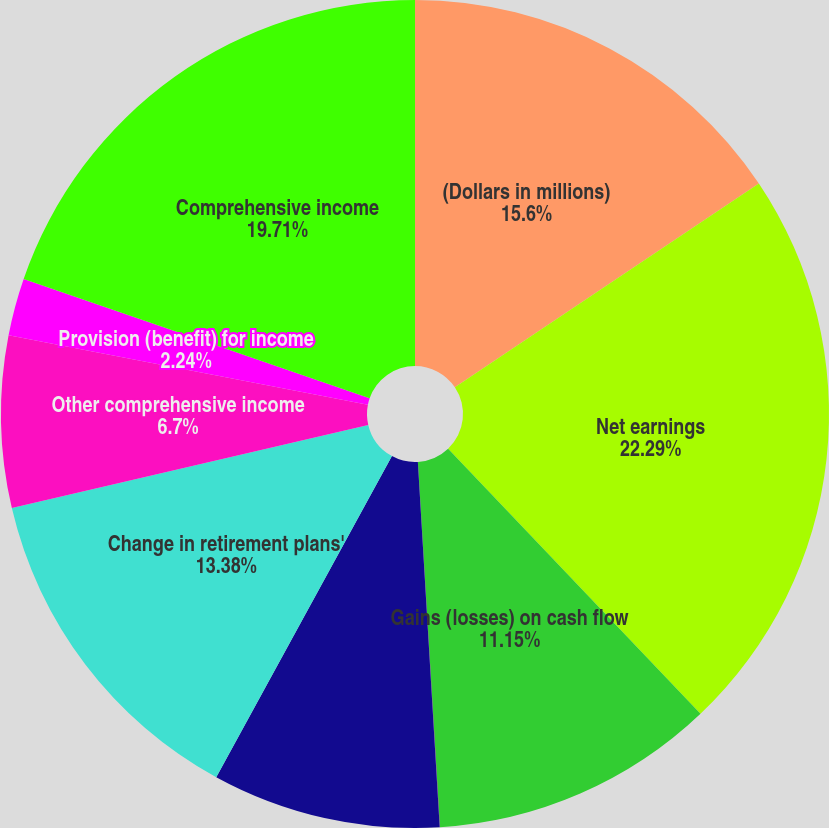Convert chart. <chart><loc_0><loc_0><loc_500><loc_500><pie_chart><fcel>(Dollars in millions)<fcel>Net earnings<fcel>Gains (losses) on cash flow<fcel>Unrealized gains (losses) on<fcel>Foreign currency translation<fcel>Change in retirement plans'<fcel>Other comprehensive income<fcel>Provision (benefit) for income<fcel>Comprehensive income<nl><fcel>15.6%<fcel>22.29%<fcel>11.15%<fcel>0.01%<fcel>8.92%<fcel>13.38%<fcel>6.7%<fcel>2.24%<fcel>19.71%<nl></chart> 